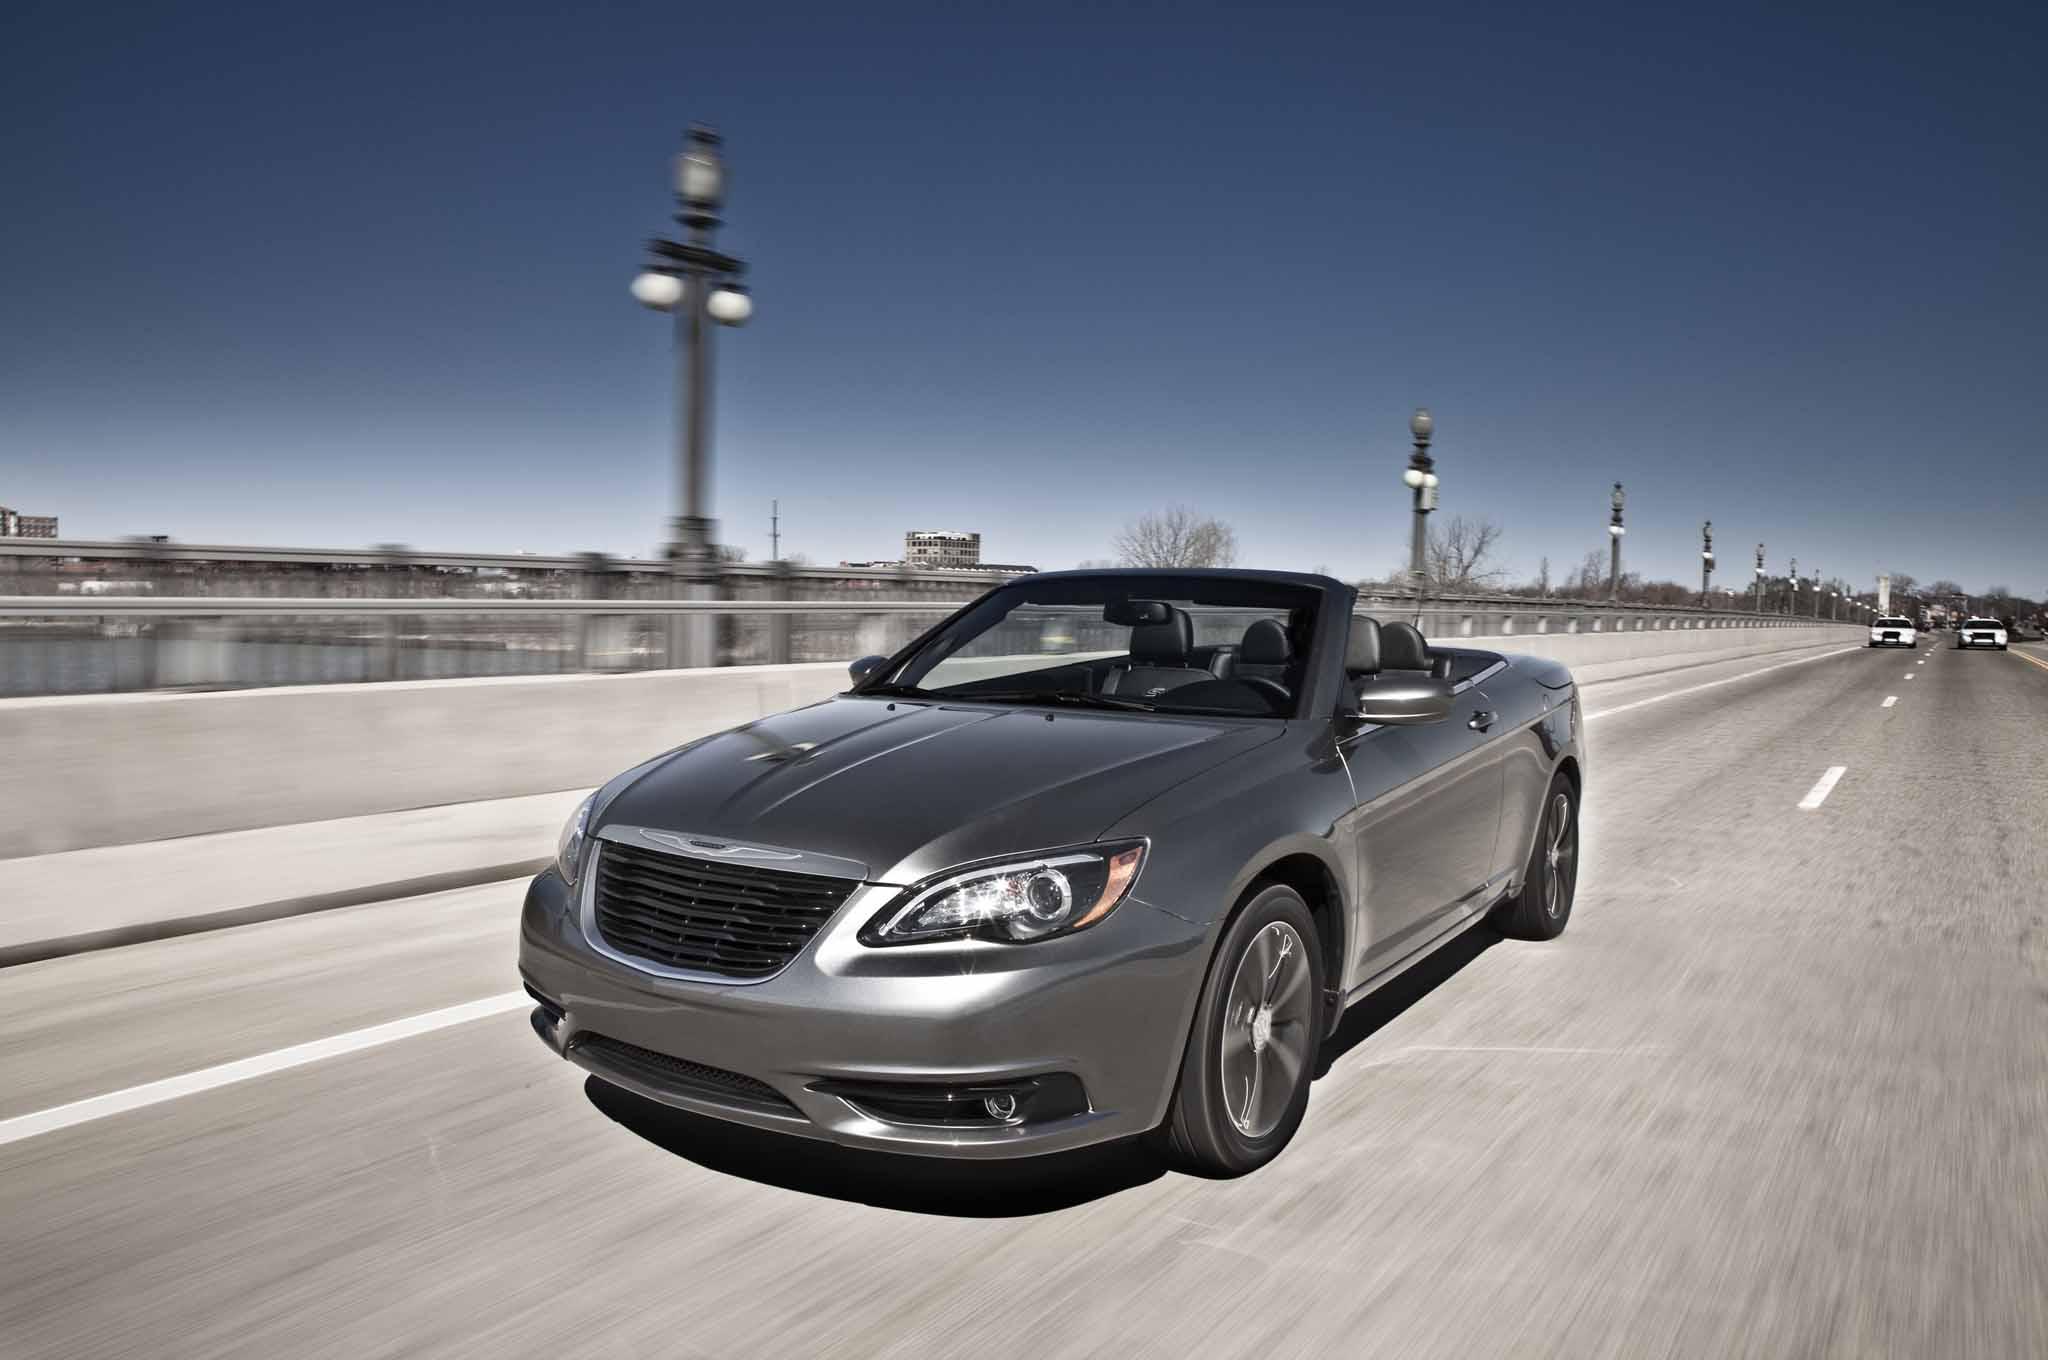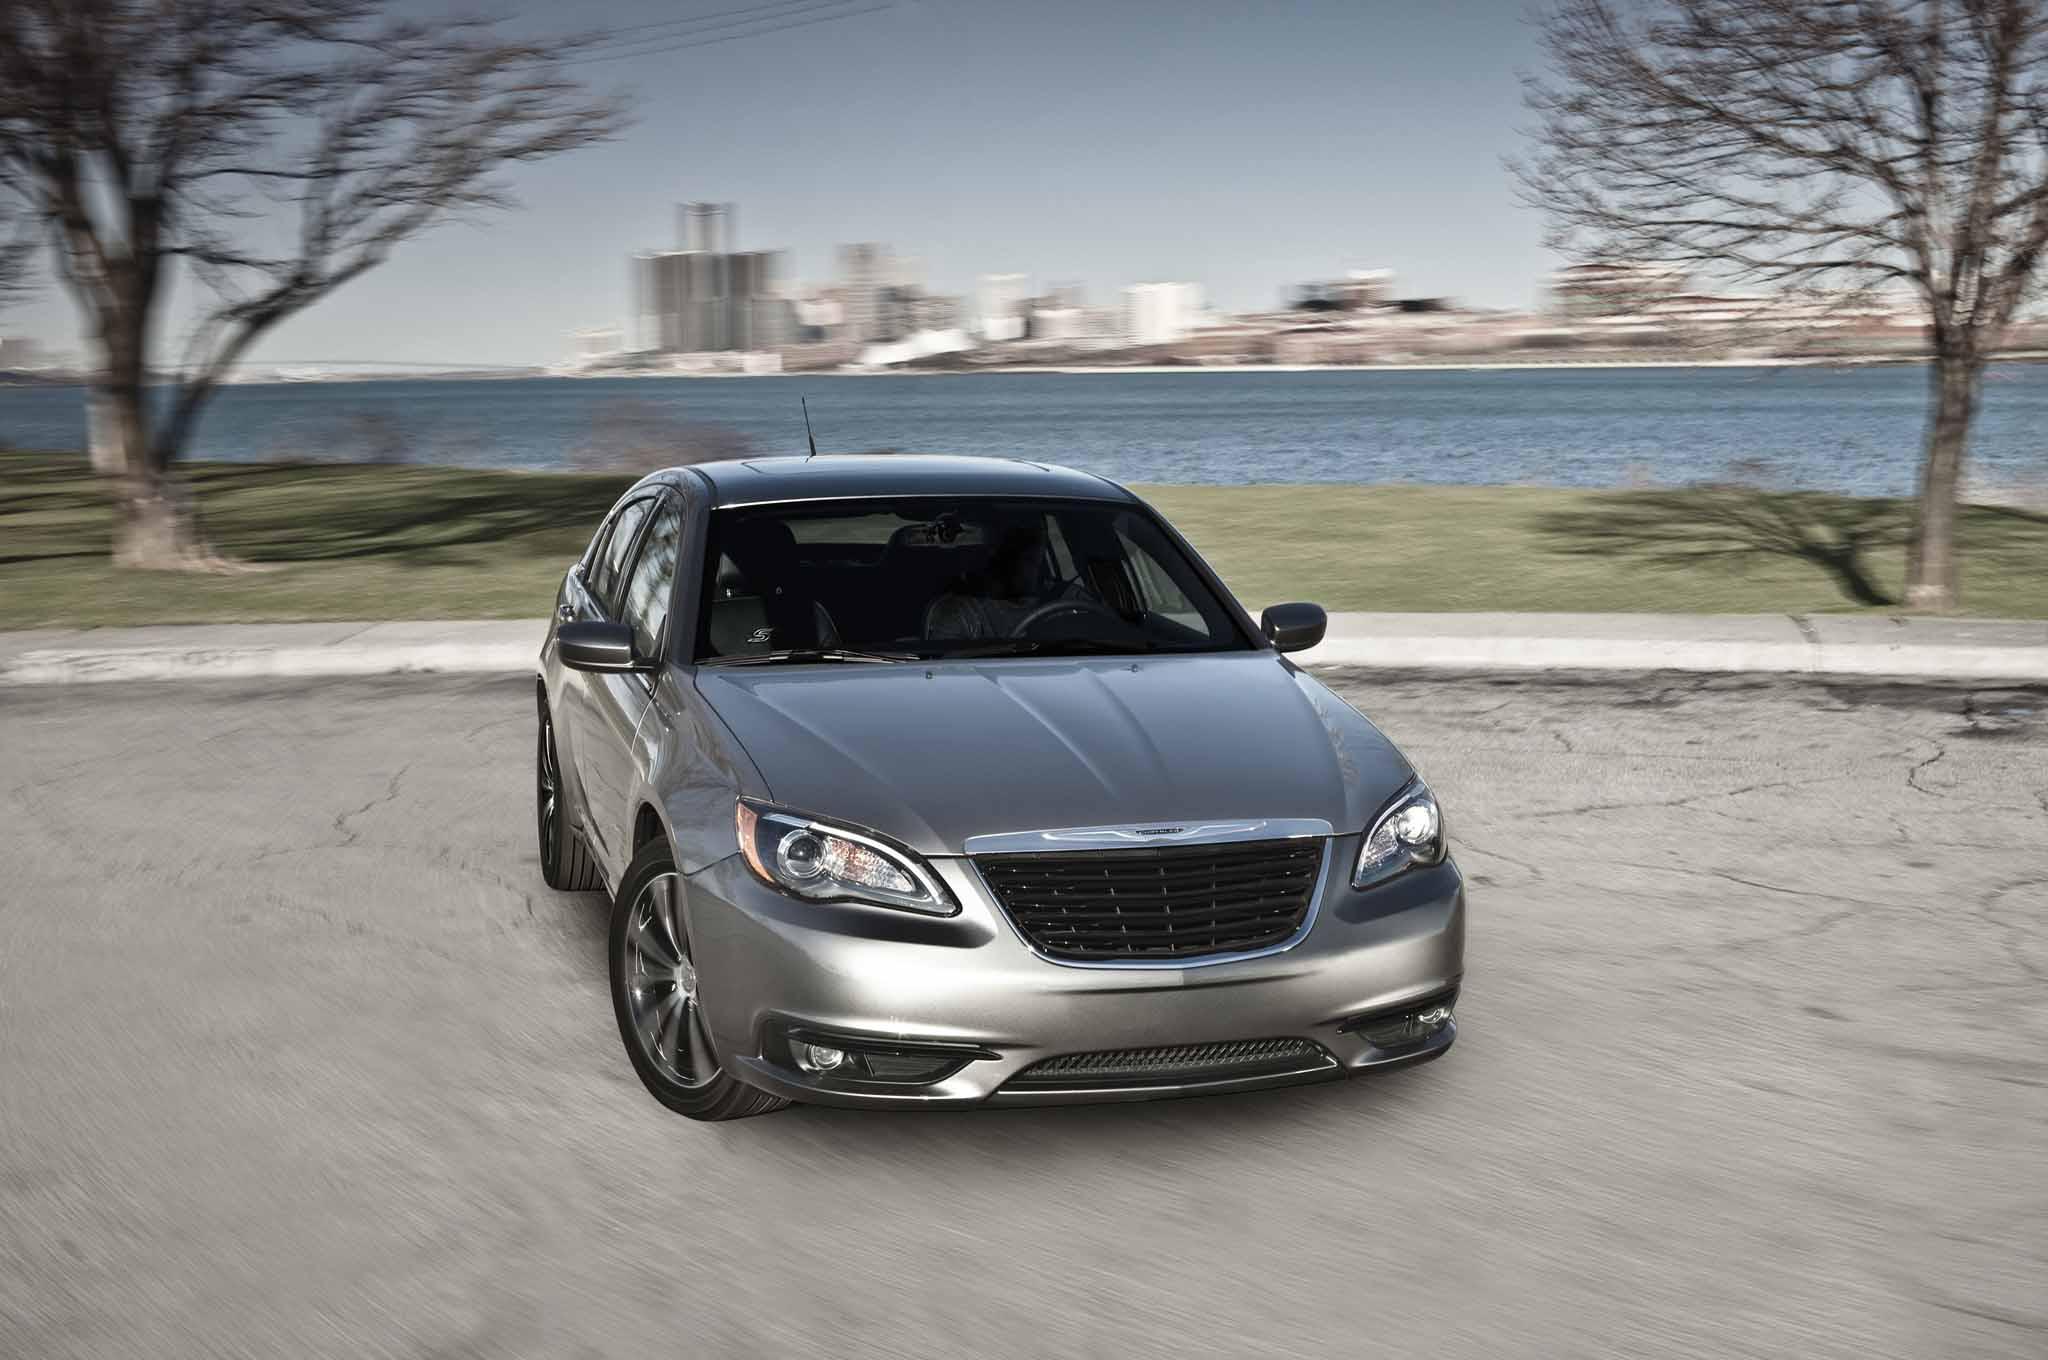The first image is the image on the left, the second image is the image on the right. Analyze the images presented: Is the assertion "One parked car has it's top fully open, and the other parked car has it's hood fully closed." valid? Answer yes or no. No. The first image is the image on the left, the second image is the image on the right. For the images displayed, is the sentence "The car in the image on the right has a top." factually correct? Answer yes or no. Yes. 